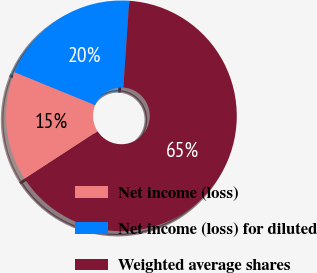<chart> <loc_0><loc_0><loc_500><loc_500><pie_chart><fcel>Net income (loss)<fcel>Net income (loss) for diluted<fcel>Weighted average shares<nl><fcel>15.37%<fcel>19.9%<fcel>64.73%<nl></chart> 